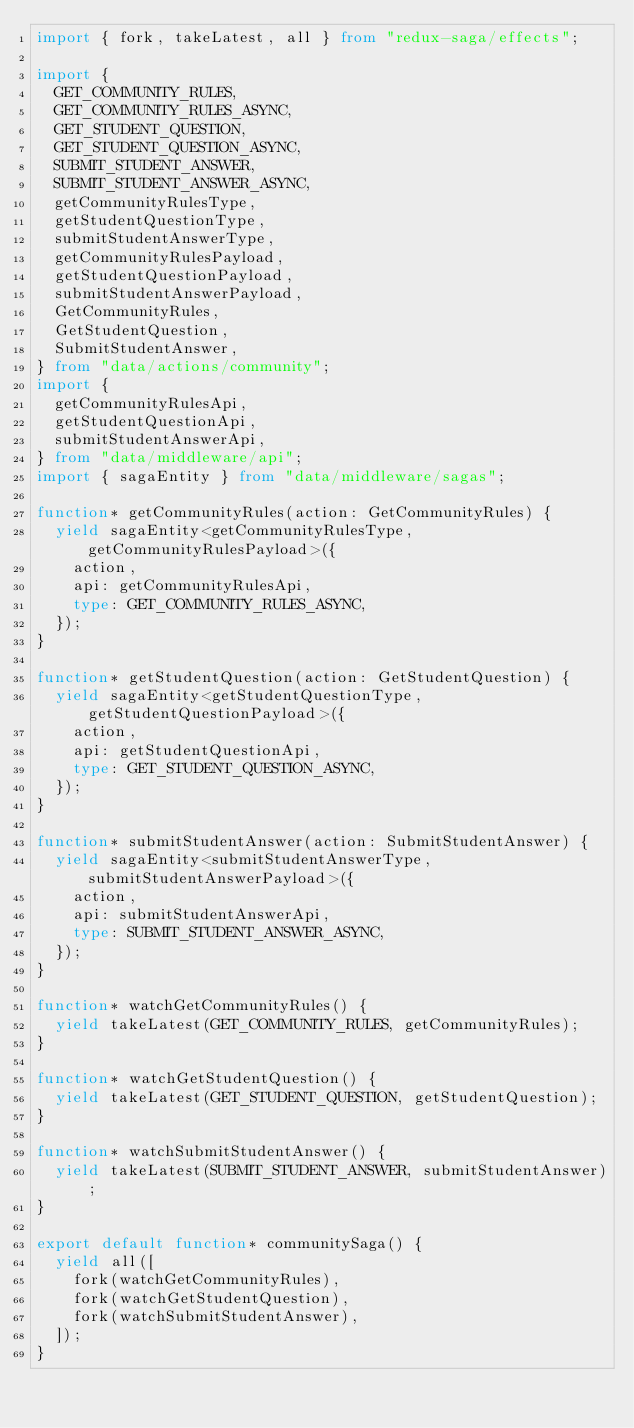Convert code to text. <code><loc_0><loc_0><loc_500><loc_500><_TypeScript_>import { fork, takeLatest, all } from "redux-saga/effects";

import {
  GET_COMMUNITY_RULES,
  GET_COMMUNITY_RULES_ASYNC,
  GET_STUDENT_QUESTION,
  GET_STUDENT_QUESTION_ASYNC,
  SUBMIT_STUDENT_ANSWER,
  SUBMIT_STUDENT_ANSWER_ASYNC,
  getCommunityRulesType,
  getStudentQuestionType,
  submitStudentAnswerType,
  getCommunityRulesPayload,
  getStudentQuestionPayload,
  submitStudentAnswerPayload,
  GetCommunityRules,
  GetStudentQuestion,
  SubmitStudentAnswer,
} from "data/actions/community";
import {
  getCommunityRulesApi,
  getStudentQuestionApi,
  submitStudentAnswerApi,
} from "data/middleware/api";
import { sagaEntity } from "data/middleware/sagas";

function* getCommunityRules(action: GetCommunityRules) {
  yield sagaEntity<getCommunityRulesType, getCommunityRulesPayload>({
    action,
    api: getCommunityRulesApi,
    type: GET_COMMUNITY_RULES_ASYNC,
  });
}

function* getStudentQuestion(action: GetStudentQuestion) {
  yield sagaEntity<getStudentQuestionType, getStudentQuestionPayload>({
    action,
    api: getStudentQuestionApi,
    type: GET_STUDENT_QUESTION_ASYNC,
  });
}

function* submitStudentAnswer(action: SubmitStudentAnswer) {
  yield sagaEntity<submitStudentAnswerType, submitStudentAnswerPayload>({
    action,
    api: submitStudentAnswerApi,
    type: SUBMIT_STUDENT_ANSWER_ASYNC,
  });
}

function* watchGetCommunityRules() {
  yield takeLatest(GET_COMMUNITY_RULES, getCommunityRules);
}

function* watchGetStudentQuestion() {
  yield takeLatest(GET_STUDENT_QUESTION, getStudentQuestion);
}

function* watchSubmitStudentAnswer() {
  yield takeLatest(SUBMIT_STUDENT_ANSWER, submitStudentAnswer);
}

export default function* communitySaga() {
  yield all([
    fork(watchGetCommunityRules),
    fork(watchGetStudentQuestion),
    fork(watchSubmitStudentAnswer),
  ]);
}
</code> 